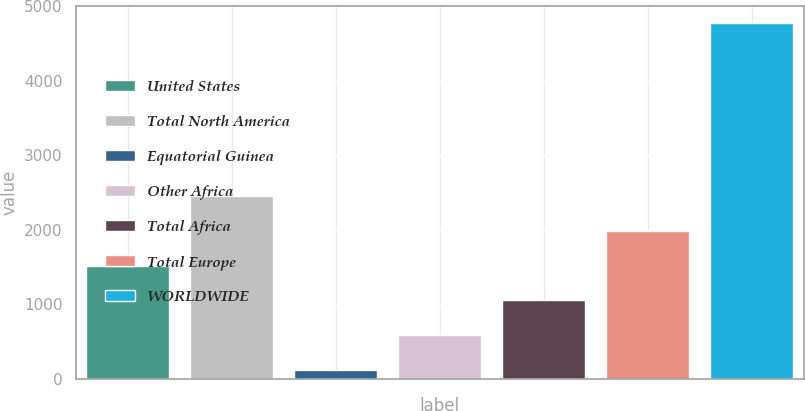<chart> <loc_0><loc_0><loc_500><loc_500><bar_chart><fcel>United States<fcel>Total North America<fcel>Equatorial Guinea<fcel>Other Africa<fcel>Total Africa<fcel>Total Europe<fcel>WORLDWIDE<nl><fcel>1516.1<fcel>2445.5<fcel>122<fcel>586.7<fcel>1051.4<fcel>1980.8<fcel>4769<nl></chart> 